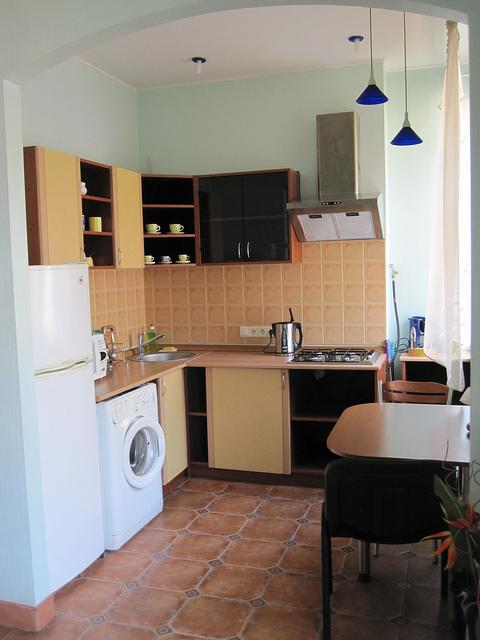What is the small white appliance?

Choices:
A) stove
B) refrigerator
C) dishwasher
D) clothes washer clothes washer 